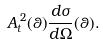<formula> <loc_0><loc_0><loc_500><loc_500>A _ { t } ^ { \, 2 } ( \theta ) \frac { d \sigma } { d \Omega } ( \theta ) .</formula> 